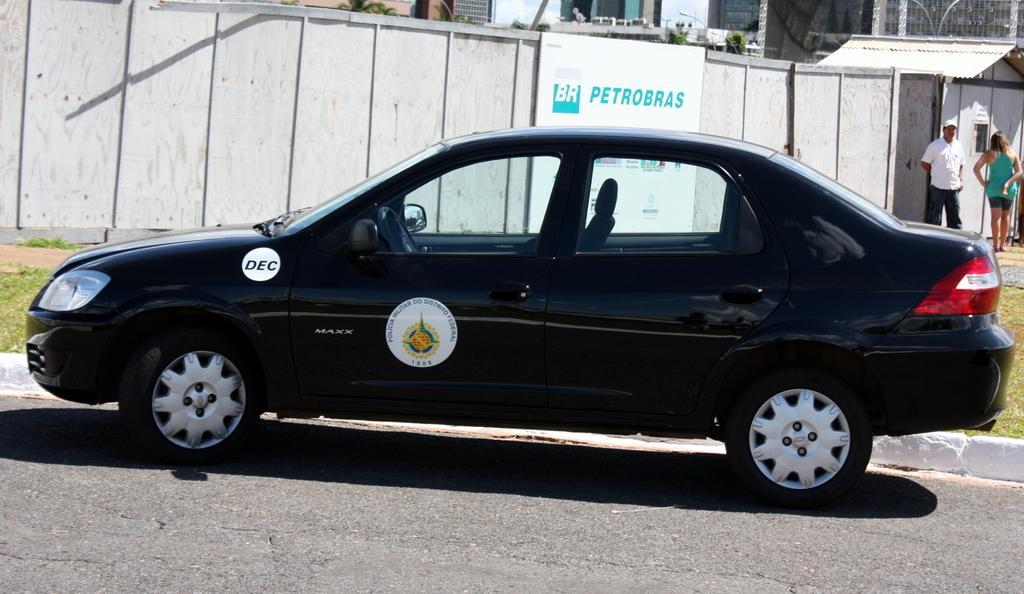In one or two sentences, can you explain what this image depicts? In this image I can see the car on the road. To the side of the car I can see the board to the wooden wall. To the right I can see two people with different color dresses. In the background I can see the shed, few plants and the buildings. 